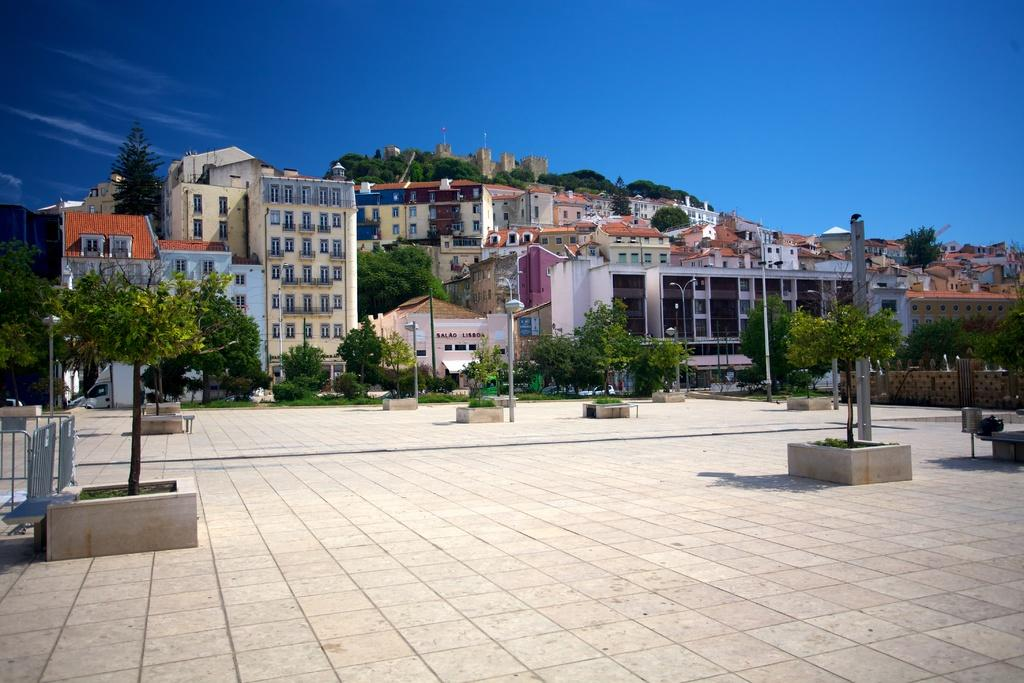What type of natural elements are in the middle of the image? There are trees and plants in the middle of the image. What else can be seen in the middle of the image besides trees and plants? There are poles in the middle of the image. What type of structures can be seen in the background of the image? There are buildings visible in the background of the image. What is visible at the top of the image? The sky is visible at the top of the image, and there are clouds in the sky. What type of ornament is hanging from the trees in the image? There is no ornament hanging from the trees in the image; only trees, plants, and poles are present. What type of insurance policy is being advertised on the buildings in the image? There is no insurance policy being advertised on the buildings in the image; only the buildings themselves are visible. 